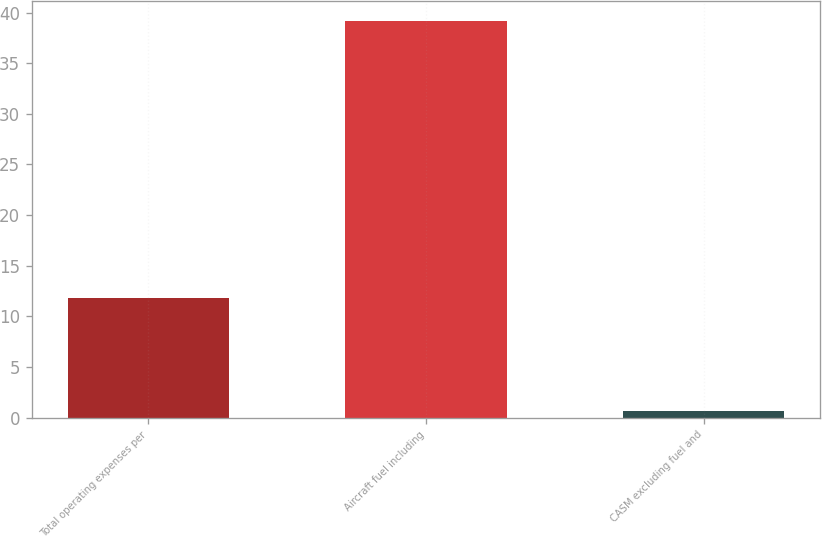<chart> <loc_0><loc_0><loc_500><loc_500><bar_chart><fcel>Total operating expenses per<fcel>Aircraft fuel including<fcel>CASM excluding fuel and<nl><fcel>11.8<fcel>39.2<fcel>0.7<nl></chart> 